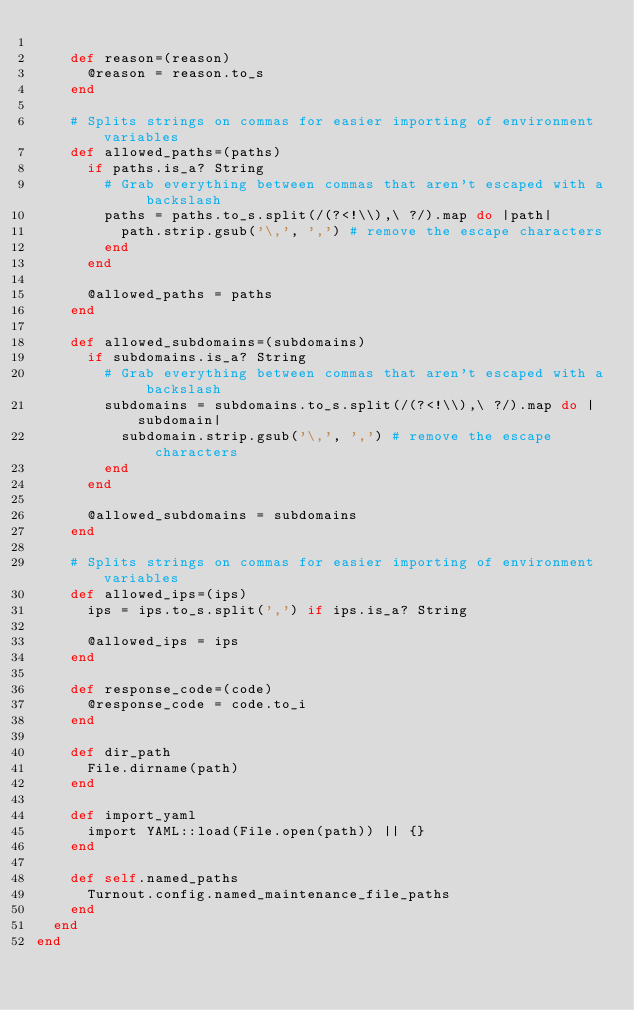<code> <loc_0><loc_0><loc_500><loc_500><_Ruby_>
    def reason=(reason)
      @reason = reason.to_s
    end

    # Splits strings on commas for easier importing of environment variables
    def allowed_paths=(paths)
      if paths.is_a? String
        # Grab everything between commas that aren't escaped with a backslash
        paths = paths.to_s.split(/(?<!\\),\ ?/).map do |path|
          path.strip.gsub('\,', ',') # remove the escape characters
        end
      end

      @allowed_paths = paths
    end
    
    def allowed_subdomains=(subdomains)
      if subdomains.is_a? String
        # Grab everything between commas that aren't escaped with a backslash
        subdomains = subdomains.to_s.split(/(?<!\\),\ ?/).map do |subdomain|
          subdomain.strip.gsub('\,', ',') # remove the escape characters
        end
      end

      @allowed_subdomains = subdomains
    end

    # Splits strings on commas for easier importing of environment variables
    def allowed_ips=(ips)
      ips = ips.to_s.split(',') if ips.is_a? String

      @allowed_ips = ips
    end

    def response_code=(code)
      @response_code = code.to_i
    end

    def dir_path
      File.dirname(path)
    end

    def import_yaml
      import YAML::load(File.open(path)) || {}
    end

    def self.named_paths
      Turnout.config.named_maintenance_file_paths
    end
  end
end
</code> 